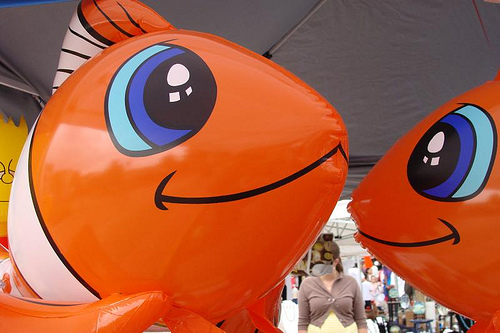<image>
Can you confirm if the woman is behind the fish? Yes. From this viewpoint, the woman is positioned behind the fish, with the fish partially or fully occluding the woman. Is there a woman in front of the fish balloon? Yes. The woman is positioned in front of the fish balloon, appearing closer to the camera viewpoint. Is the fish above the woman? Yes. The fish is positioned above the woman in the vertical space, higher up in the scene. 